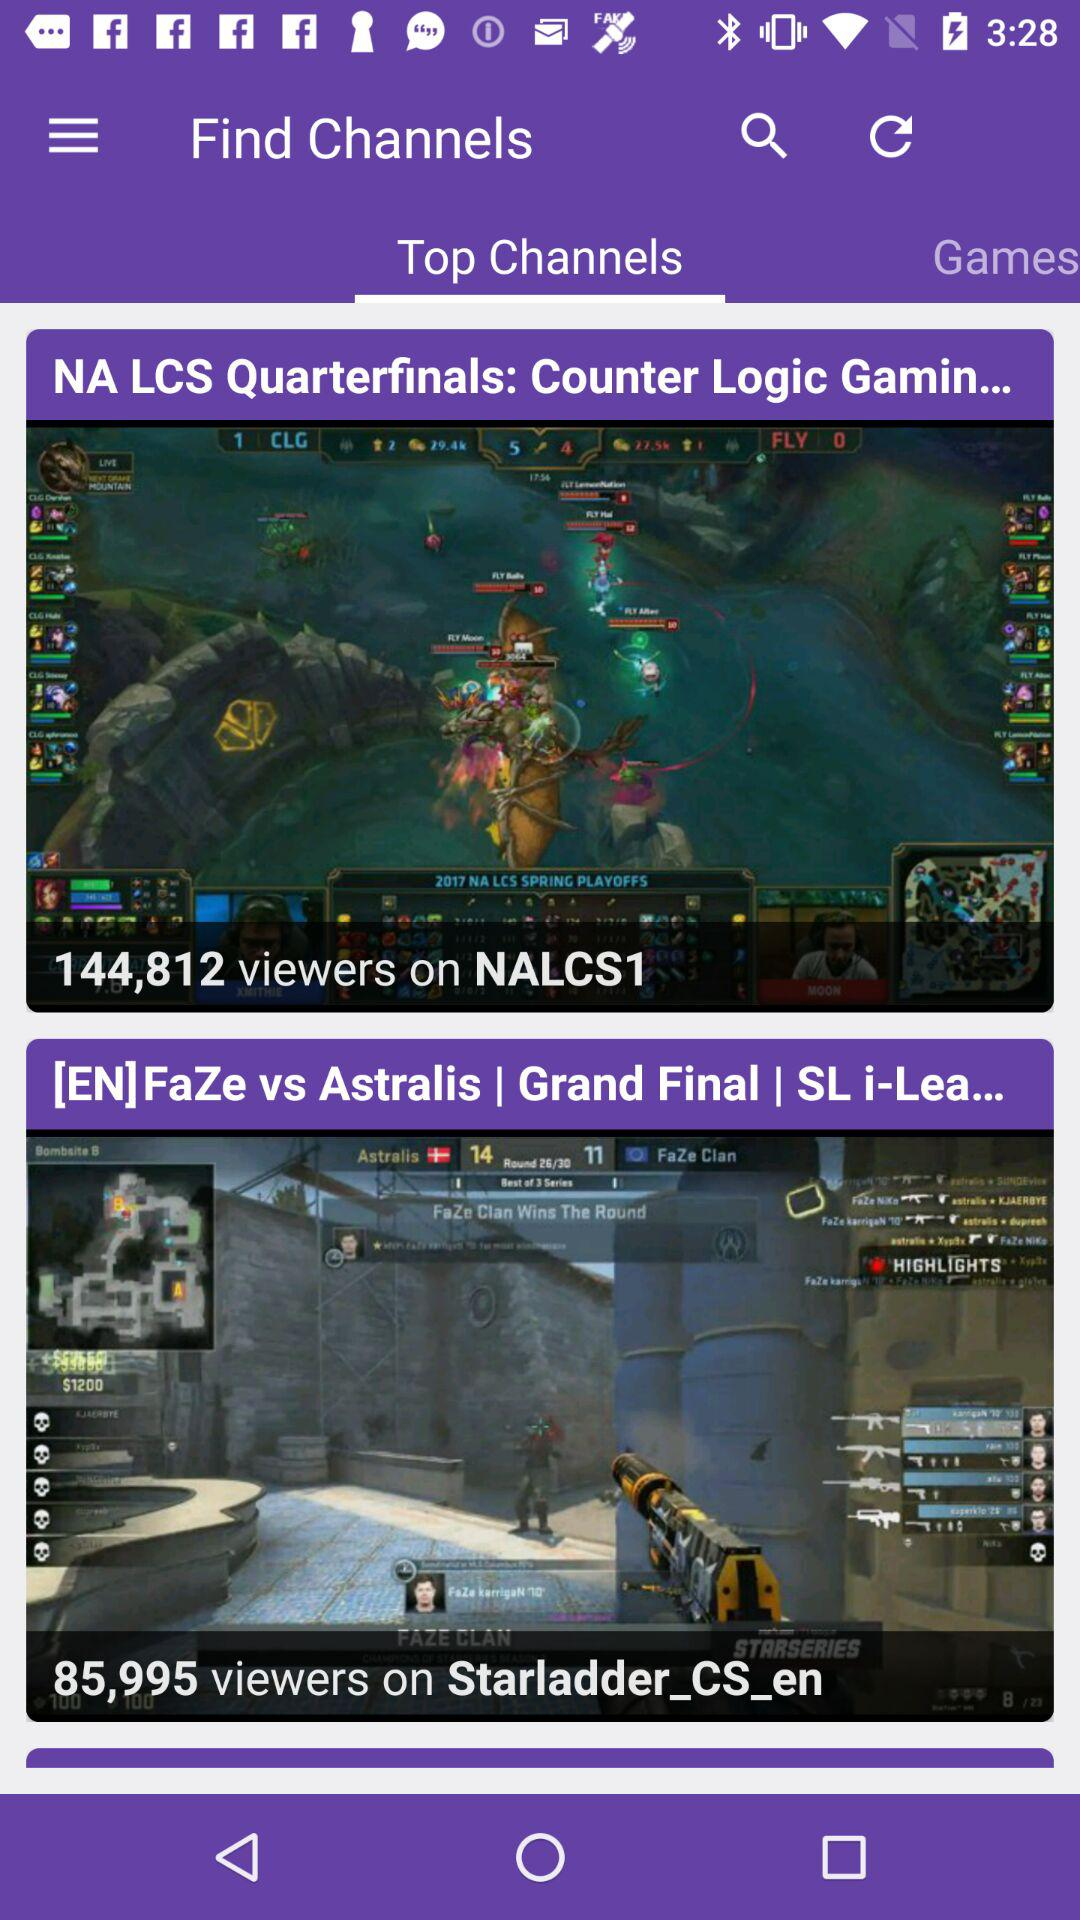How many viewers are on NALCS1 channels? There are 144,812 viewers. 